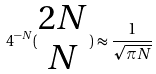<formula> <loc_0><loc_0><loc_500><loc_500>4 ^ { - N } ( \begin{matrix} 2 N \\ N \end{matrix} ) \approx \frac { 1 } { \sqrt { \pi N } }</formula> 